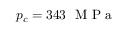Convert formula to latex. <formula><loc_0><loc_0><loc_500><loc_500>p _ { c } = 3 4 3 M P a</formula> 